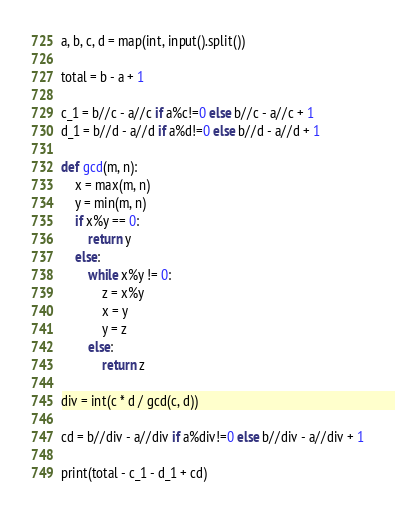<code> <loc_0><loc_0><loc_500><loc_500><_Python_>a, b, c, d = map(int, input().split())

total = b - a + 1

c_1 = b//c - a//c if a%c!=0 else b//c - a//c + 1
d_1 = b//d - a//d if a%d!=0 else b//d - a//d + 1

def gcd(m, n):
    x = max(m, n)
    y = min(m, n)
    if x%y == 0:
        return y
    else:
        while x%y != 0:
            z = x%y
            x = y
            y = z
        else:
            return z

div = int(c * d / gcd(c, d))

cd = b//div - a//div if a%div!=0 else b//div - a//div + 1

print(total - c_1 - d_1 + cd)
</code> 